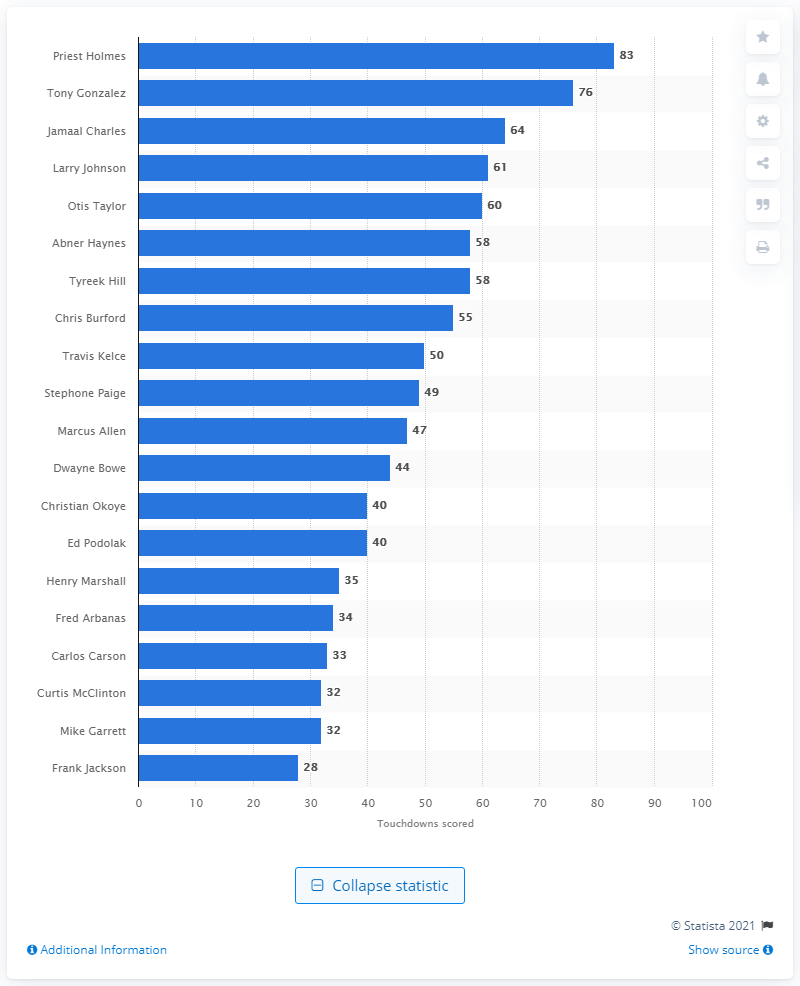Point out several critical features in this image. The career touchdown leader of the Kansas City Chiefs is Priest Holmes. I declare that Priest Holmes has a total of 83 career touchdowns for the Kansas City Chiefs. 